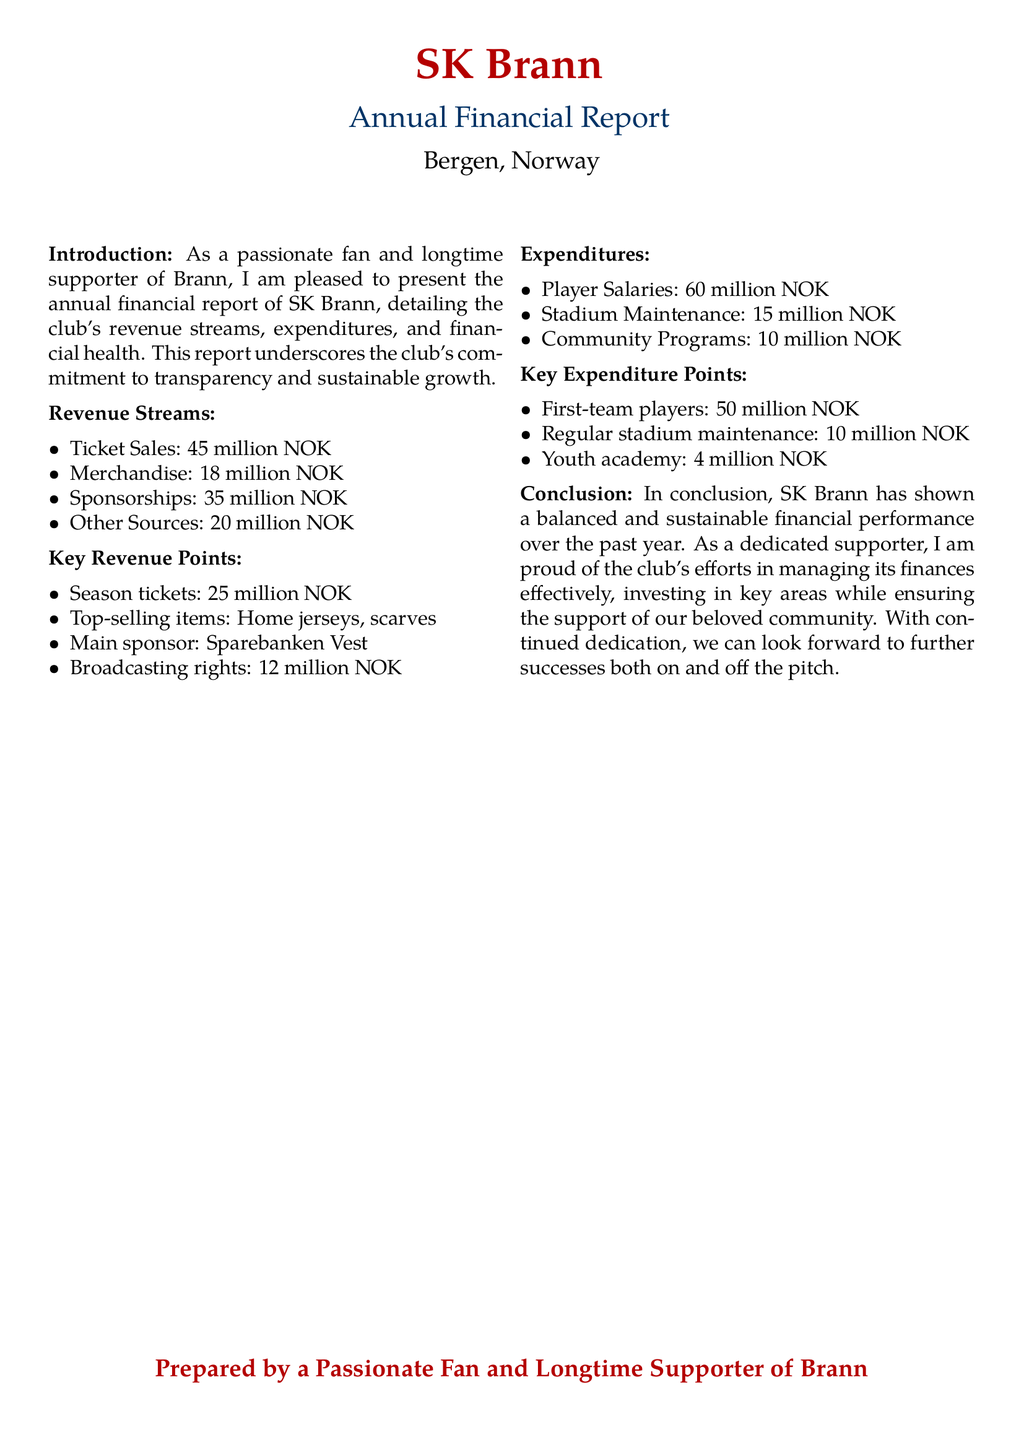What is SK Brann's total revenue? The total revenue is the sum of all revenue streams: 45 million + 18 million + 35 million + 20 million = 118 million NOK.
Answer: 118 million NOK What is the main sponsorship source for SK Brann? The document states that the main sponsor is Sparebanken Vest.
Answer: Sparebanken Vest What is the expenditure on player salaries? The document lists player salaries as an expenditure totaling 60 million NOK.
Answer: 60 million NOK How much was spent on community programs? The expenditures section specifies that 10 million NOK was spent on community programs.
Answer: 10 million NOK What is the revenue from merchandise sales? According to the document, merchandise sales generated 18 million NOK in revenue.
Answer: 18 million NOK What are the most popular merchandise items? The report mentions that home jerseys and scarves are the top-selling items.
Answer: Home jerseys, scarves How much did SK Brann allocate for stadium maintenance? The expenditures state that stadium maintenance costs amounted to 15 million NOK.
Answer: 15 million NOK What is the amount derived from broadcasting rights? The document specifies that broadcasting rights amounted to 12 million NOK.
Answer: 12 million NOK What was the expenditure on the youth academy? The report indicates that the youth academy received 4 million NOK in funding.
Answer: 4 million NOK 